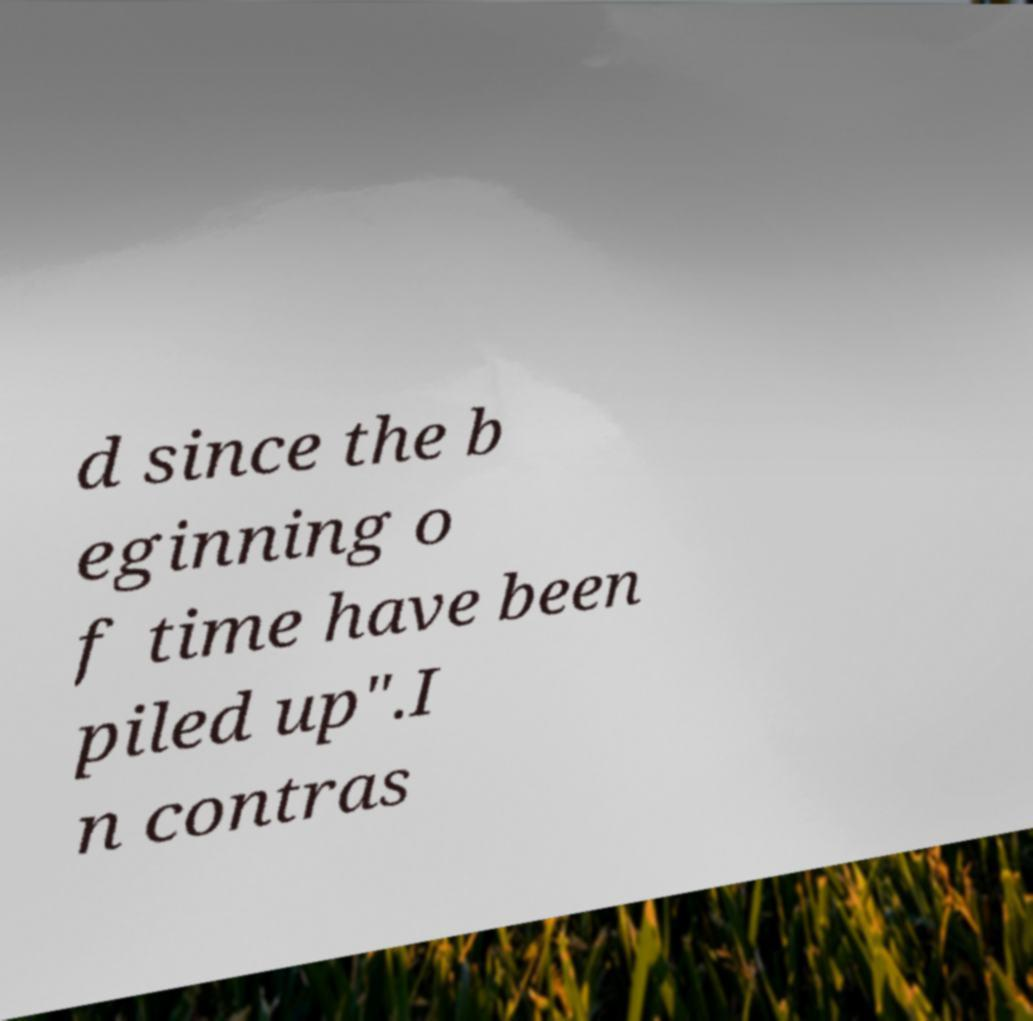I need the written content from this picture converted into text. Can you do that? d since the b eginning o f time have been piled up".I n contras 